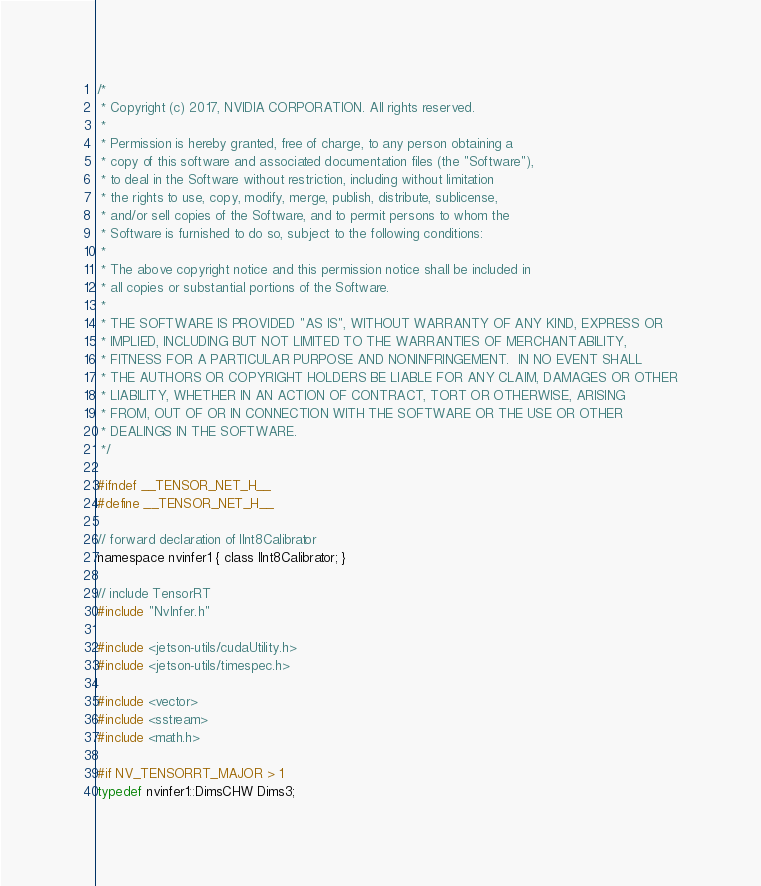Convert code to text. <code><loc_0><loc_0><loc_500><loc_500><_C_>/*
 * Copyright (c) 2017, NVIDIA CORPORATION. All rights reserved.
 *
 * Permission is hereby granted, free of charge, to any person obtaining a
 * copy of this software and associated documentation files (the "Software"),
 * to deal in the Software without restriction, including without limitation
 * the rights to use, copy, modify, merge, publish, distribute, sublicense,
 * and/or sell copies of the Software, and to permit persons to whom the
 * Software is furnished to do so, subject to the following conditions:
 *
 * The above copyright notice and this permission notice shall be included in
 * all copies or substantial portions of the Software.
 *
 * THE SOFTWARE IS PROVIDED "AS IS", WITHOUT WARRANTY OF ANY KIND, EXPRESS OR
 * IMPLIED, INCLUDING BUT NOT LIMITED TO THE WARRANTIES OF MERCHANTABILITY,
 * FITNESS FOR A PARTICULAR PURPOSE AND NONINFRINGEMENT.  IN NO EVENT SHALL
 * THE AUTHORS OR COPYRIGHT HOLDERS BE LIABLE FOR ANY CLAIM, DAMAGES OR OTHER
 * LIABILITY, WHETHER IN AN ACTION OF CONTRACT, TORT OR OTHERWISE, ARISING
 * FROM, OUT OF OR IN CONNECTION WITH THE SOFTWARE OR THE USE OR OTHER
 * DEALINGS IN THE SOFTWARE.
 */
 
#ifndef __TENSOR_NET_H__
#define __TENSOR_NET_H__

// forward declaration of IInt8Calibrator
namespace nvinfer1 { class IInt8Calibrator; }

// include TensorRT
#include "NvInfer.h"

#include <jetson-utils/cudaUtility.h>
#include <jetson-utils/timespec.h>

#include <vector>
#include <sstream>
#include <math.h>

#if NV_TENSORRT_MAJOR > 1
typedef nvinfer1::DimsCHW Dims3;
</code> 